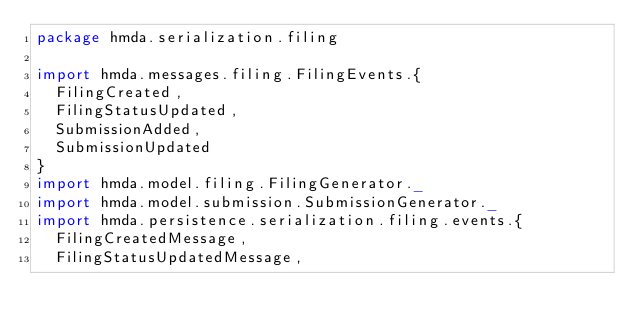<code> <loc_0><loc_0><loc_500><loc_500><_Scala_>package hmda.serialization.filing

import hmda.messages.filing.FilingEvents.{
  FilingCreated,
  FilingStatusUpdated,
  SubmissionAdded,
  SubmissionUpdated
}
import hmda.model.filing.FilingGenerator._
import hmda.model.submission.SubmissionGenerator._
import hmda.persistence.serialization.filing.events.{
  FilingCreatedMessage,
  FilingStatusUpdatedMessage,</code> 